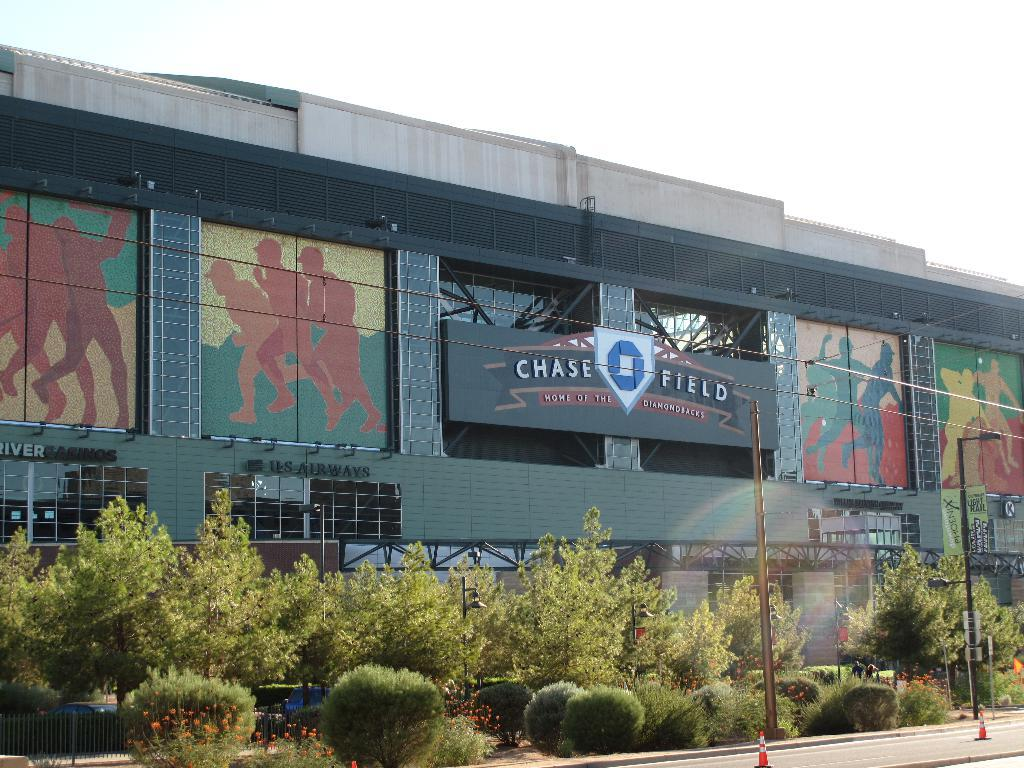What type of venue is depicted in the image? There is a baseball park in the image. What can be seen in front of the baseball park? There are many plants and trees in front of the baseball park. What color crayon is being used to write the caption in the image? There is no caption or crayon present in the image. 